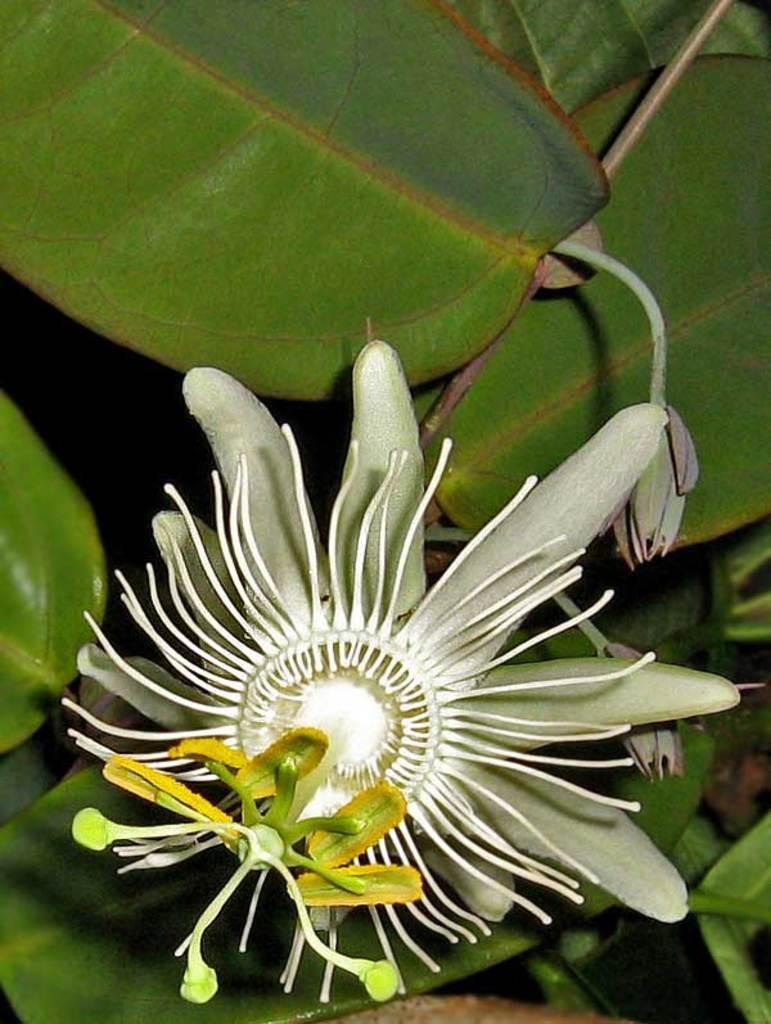Describe this image in one or two sentences. In this image we can see a flower, buds and leaves. 